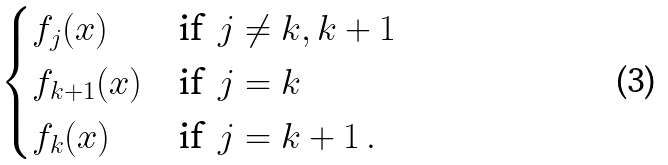<formula> <loc_0><loc_0><loc_500><loc_500>\begin{cases} f _ { j } ( x ) & \text {if } \, j \neq k , k + 1 \\ f _ { k + 1 } ( x ) & \text {if } \, j = k \\ f _ { k } ( x ) & \text {if } \, j = k + 1 \, . \end{cases}</formula> 